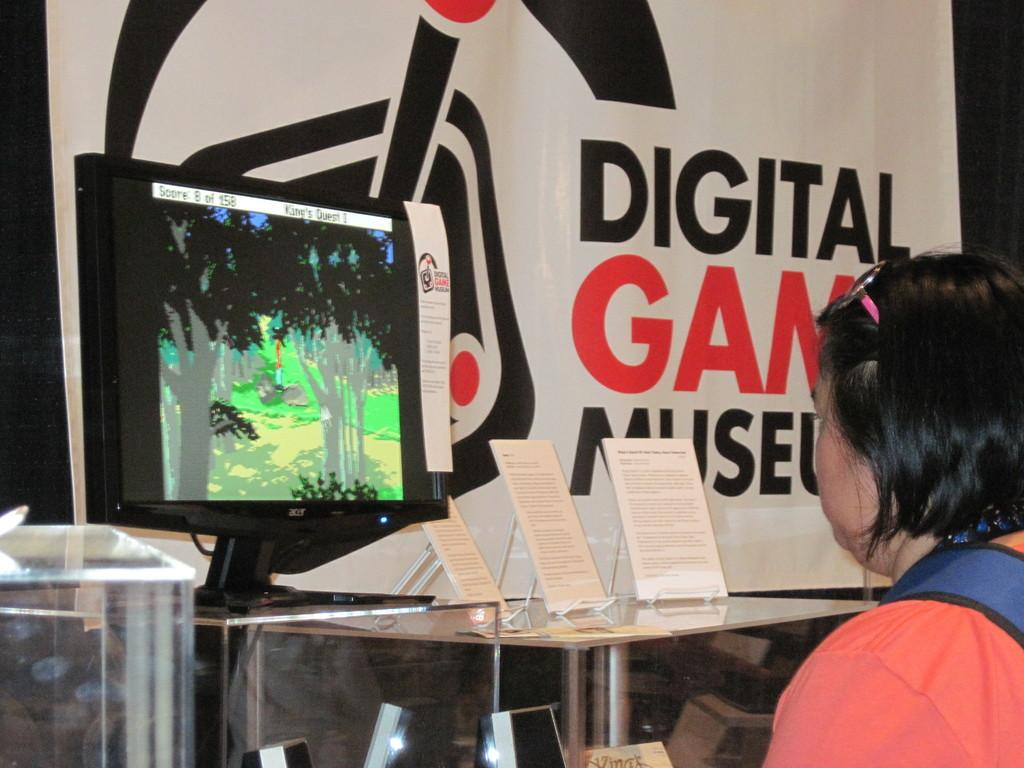Who is present in the image? There is a woman in the image. What is the woman doing in the image? The woman is sitting in front of a system. Where is the system located? The system is on a table. What else can be seen on the table? There are boards placed on the table. What can be seen in the background of the image? There is a banner visible in the background. What type of ornament is the woman using to cut the boards in the image? There is no ornament present in the image, nor is the woman cutting any boards. 